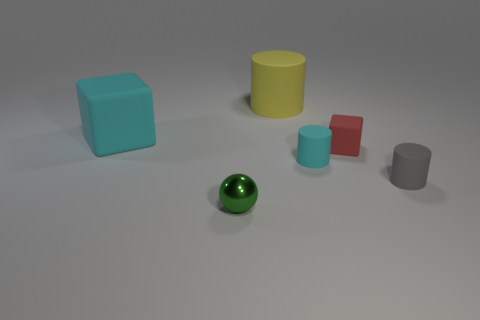What size is the block left of the small green thing?
Your response must be concise. Large. There is a object that is both in front of the large matte block and left of the tiny cyan cylinder; what is its shape?
Keep it short and to the point. Sphere. How many other things are the same shape as the big yellow rubber object?
Provide a short and direct response. 2. The rubber block that is the same size as the metal sphere is what color?
Offer a terse response. Red. What number of things are spheres or tiny red things?
Provide a short and direct response. 2. There is a red cube; are there any red cubes in front of it?
Provide a succinct answer. No. Are there any tiny blocks that have the same material as the large cube?
Provide a short and direct response. Yes. What is the size of the matte cylinder that is the same color as the big block?
Provide a short and direct response. Small. What number of balls are purple shiny objects or big cyan rubber things?
Ensure brevity in your answer.  0. Is the number of small gray things left of the green metallic ball greater than the number of green metallic objects on the left side of the big cyan matte thing?
Make the answer very short. No. 